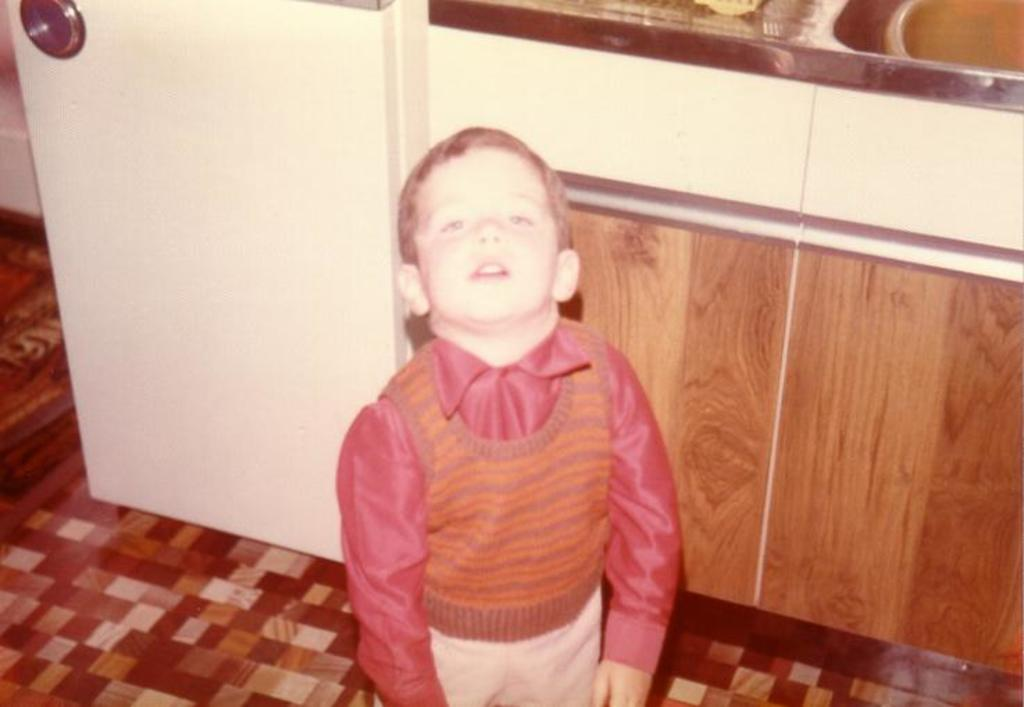What is the main subject of the image? The main subject of the image is a kid. Where is the kid standing? The kid is standing on a floor. What type of floor can be seen in the background of the image? There is a kitchen floor visible in the background of the image. What type of bun is the kid holding in the image? There is no bun present in the image; the kid is not holding any object. 